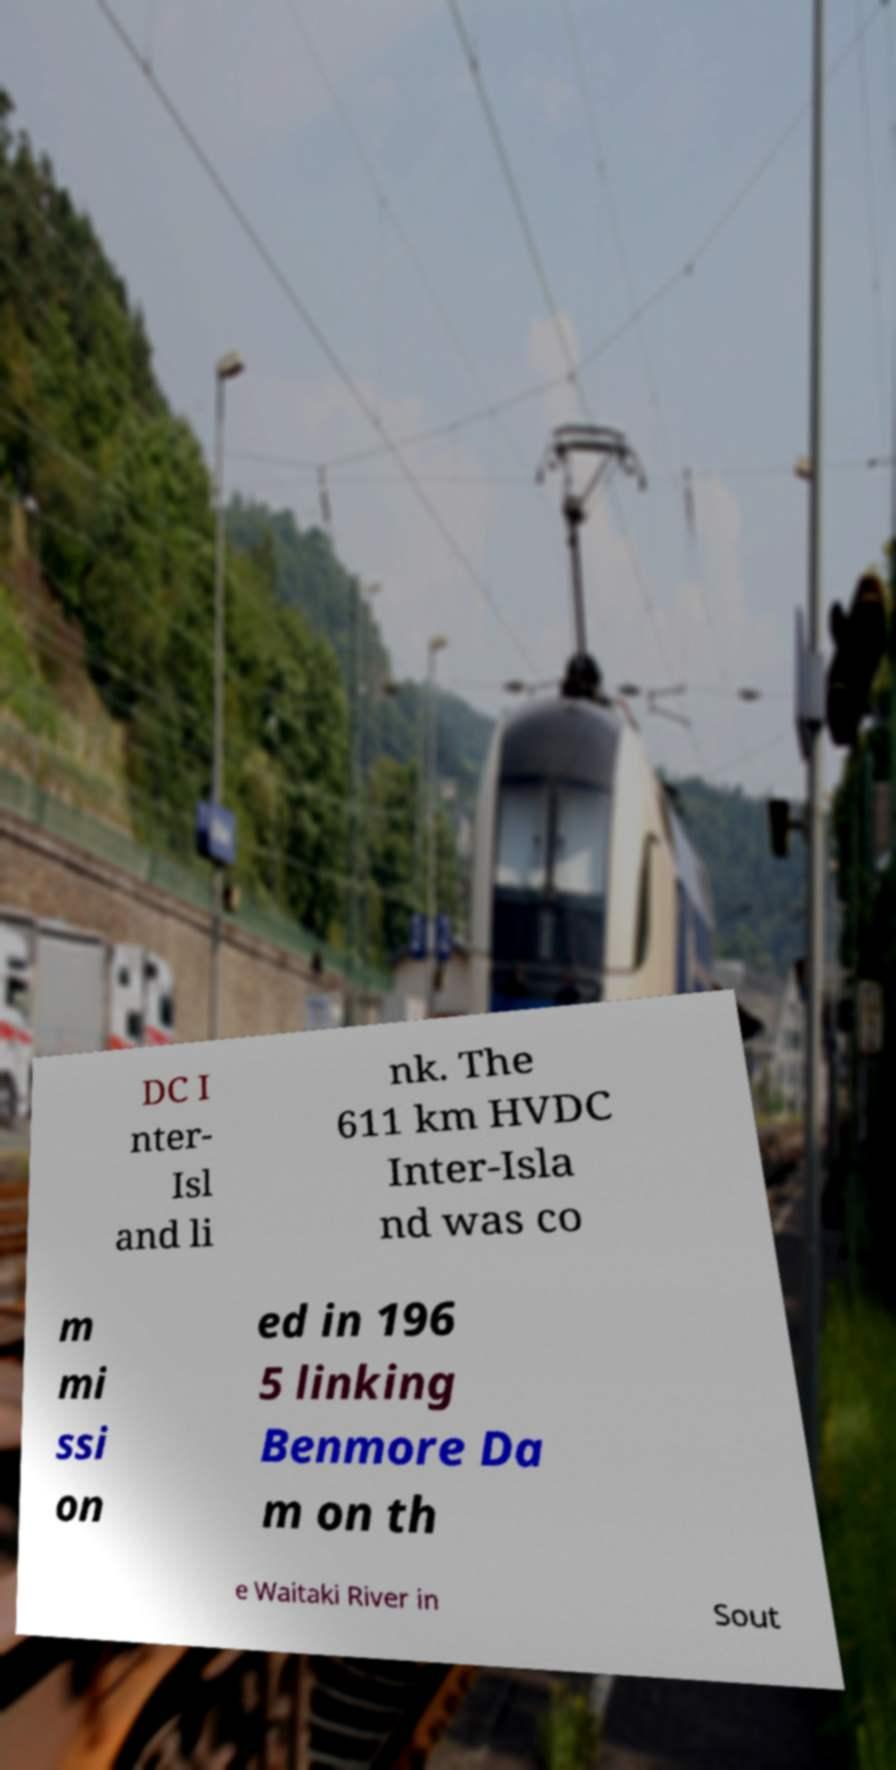Could you assist in decoding the text presented in this image and type it out clearly? DC I nter- Isl and li nk. The 611 km HVDC Inter-Isla nd was co m mi ssi on ed in 196 5 linking Benmore Da m on th e Waitaki River in Sout 